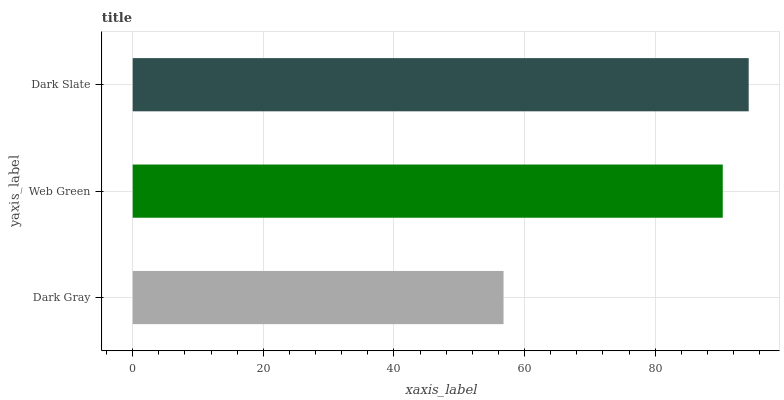Is Dark Gray the minimum?
Answer yes or no. Yes. Is Dark Slate the maximum?
Answer yes or no. Yes. Is Web Green the minimum?
Answer yes or no. No. Is Web Green the maximum?
Answer yes or no. No. Is Web Green greater than Dark Gray?
Answer yes or no. Yes. Is Dark Gray less than Web Green?
Answer yes or no. Yes. Is Dark Gray greater than Web Green?
Answer yes or no. No. Is Web Green less than Dark Gray?
Answer yes or no. No. Is Web Green the high median?
Answer yes or no. Yes. Is Web Green the low median?
Answer yes or no. Yes. Is Dark Gray the high median?
Answer yes or no. No. Is Dark Gray the low median?
Answer yes or no. No. 